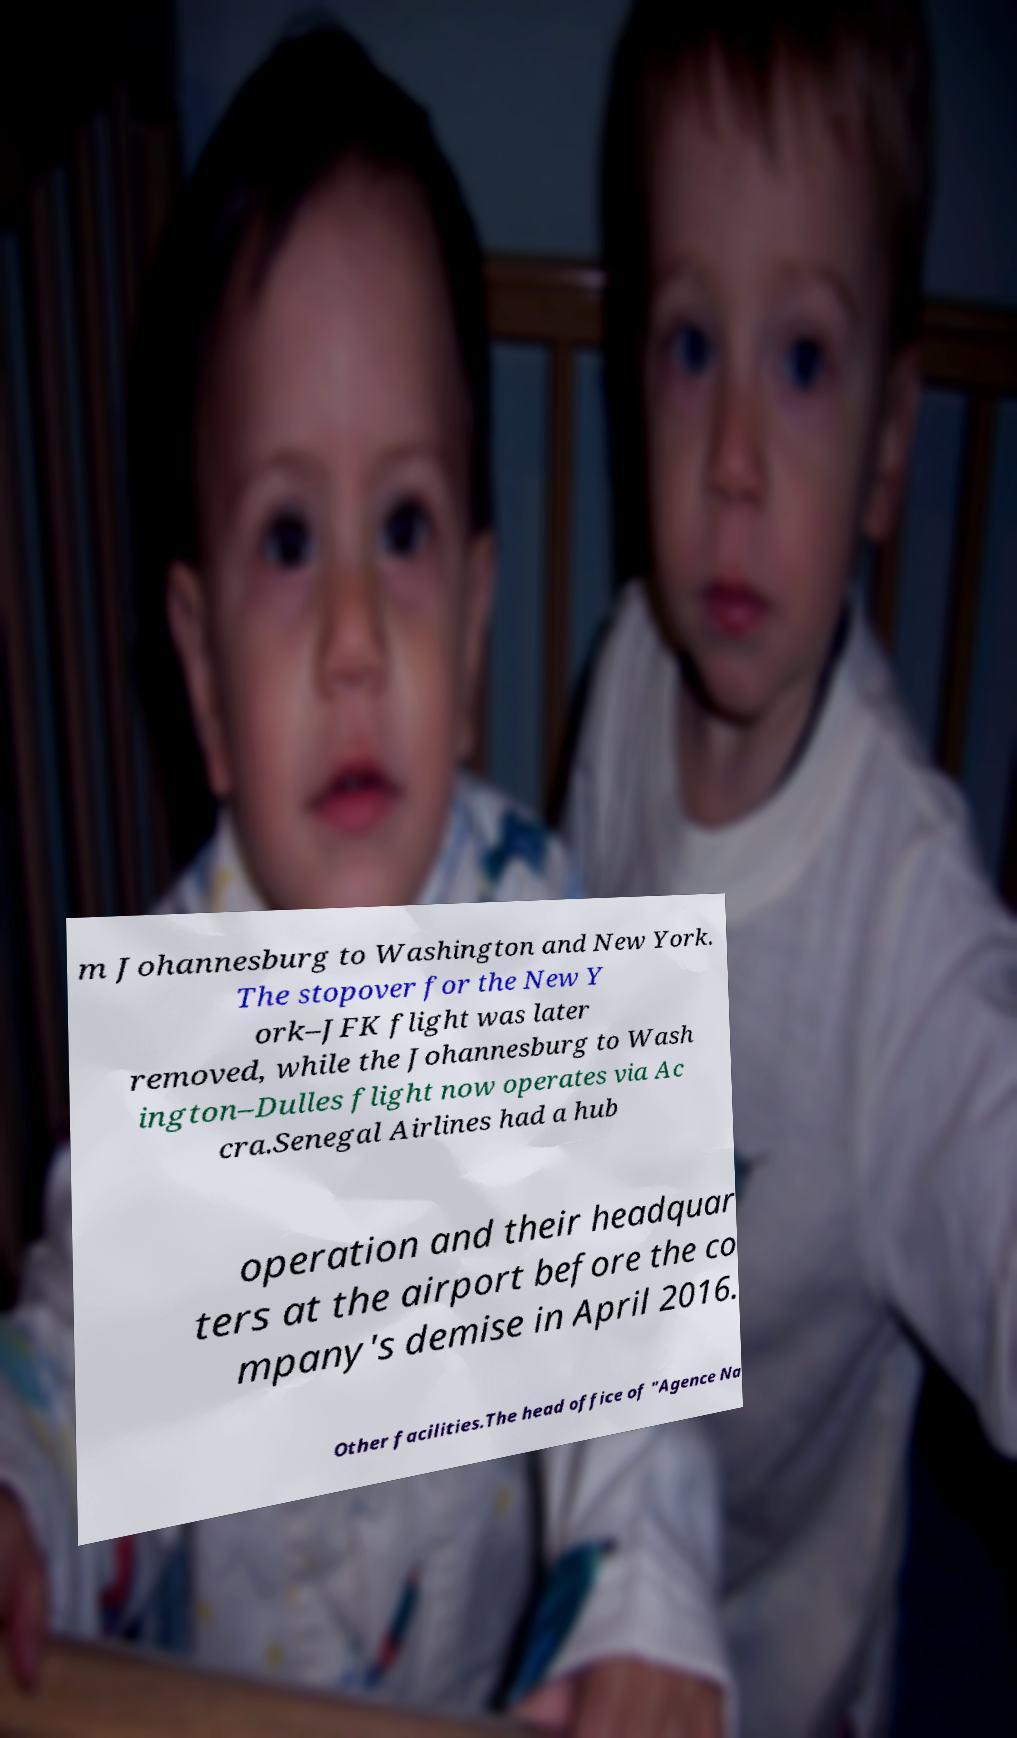I need the written content from this picture converted into text. Can you do that? m Johannesburg to Washington and New York. The stopover for the New Y ork–JFK flight was later removed, while the Johannesburg to Wash ington–Dulles flight now operates via Ac cra.Senegal Airlines had a hub operation and their headquar ters at the airport before the co mpany's demise in April 2016. Other facilities.The head office of "Agence Na 